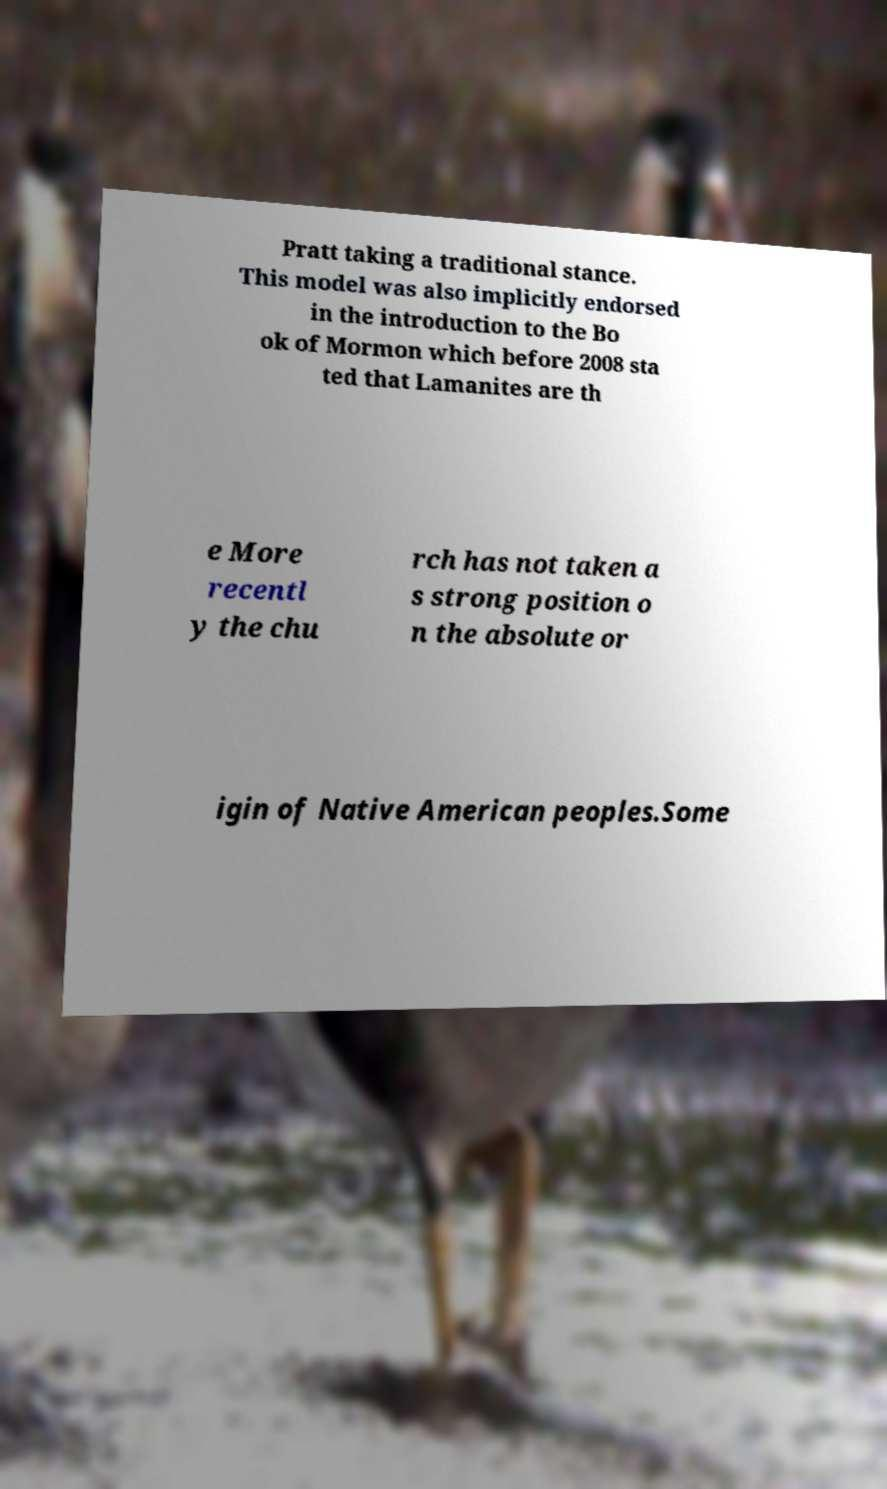I need the written content from this picture converted into text. Can you do that? Pratt taking a traditional stance. This model was also implicitly endorsed in the introduction to the Bo ok of Mormon which before 2008 sta ted that Lamanites are th e More recentl y the chu rch has not taken a s strong position o n the absolute or igin of Native American peoples.Some 